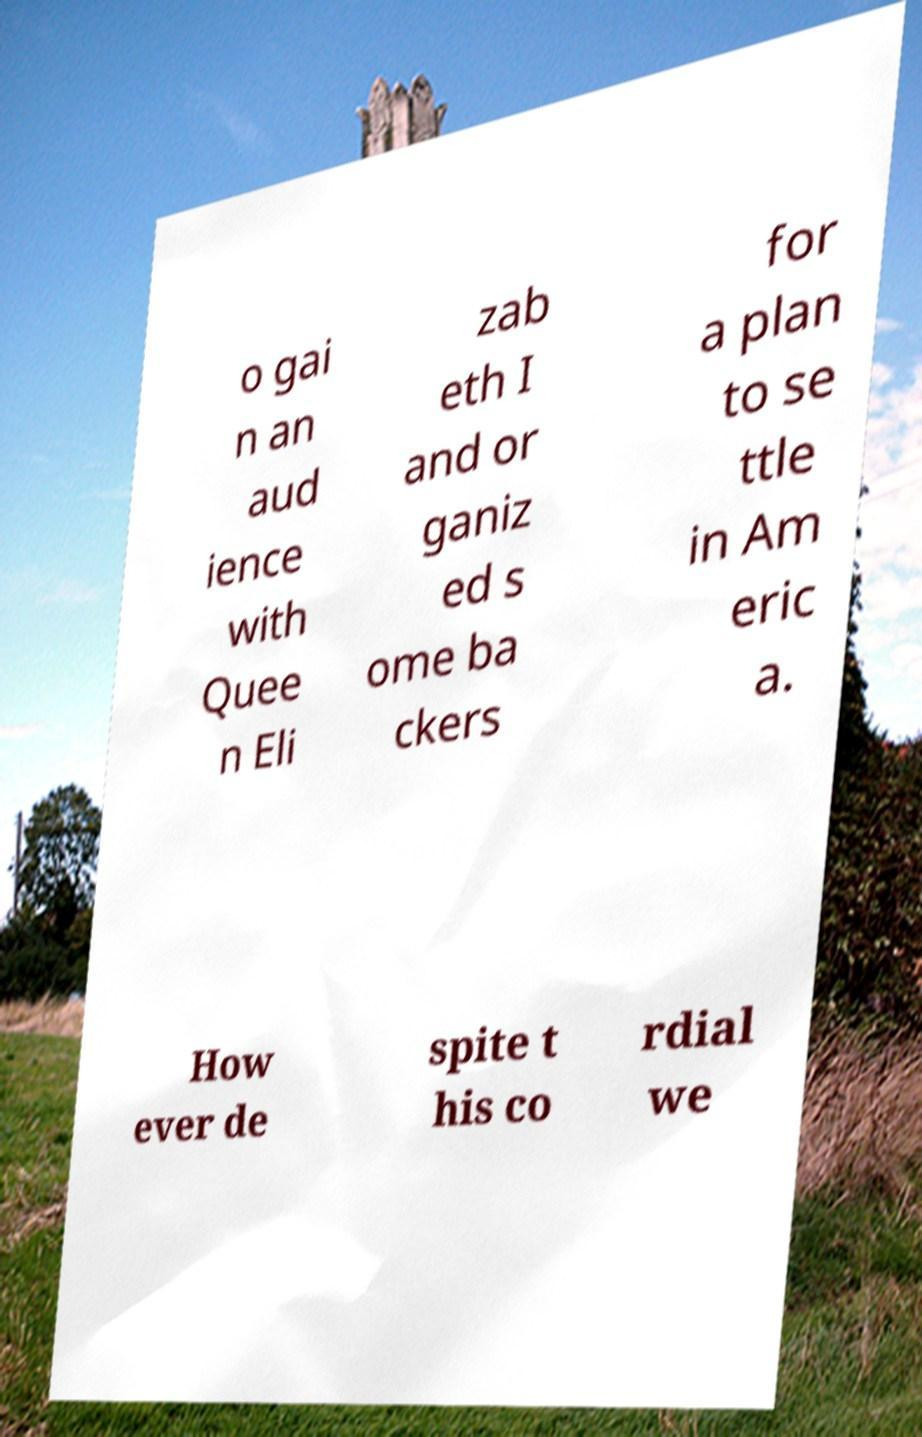Please identify and transcribe the text found in this image. o gai n an aud ience with Quee n Eli zab eth I and or ganiz ed s ome ba ckers for a plan to se ttle in Am eric a. How ever de spite t his co rdial we 